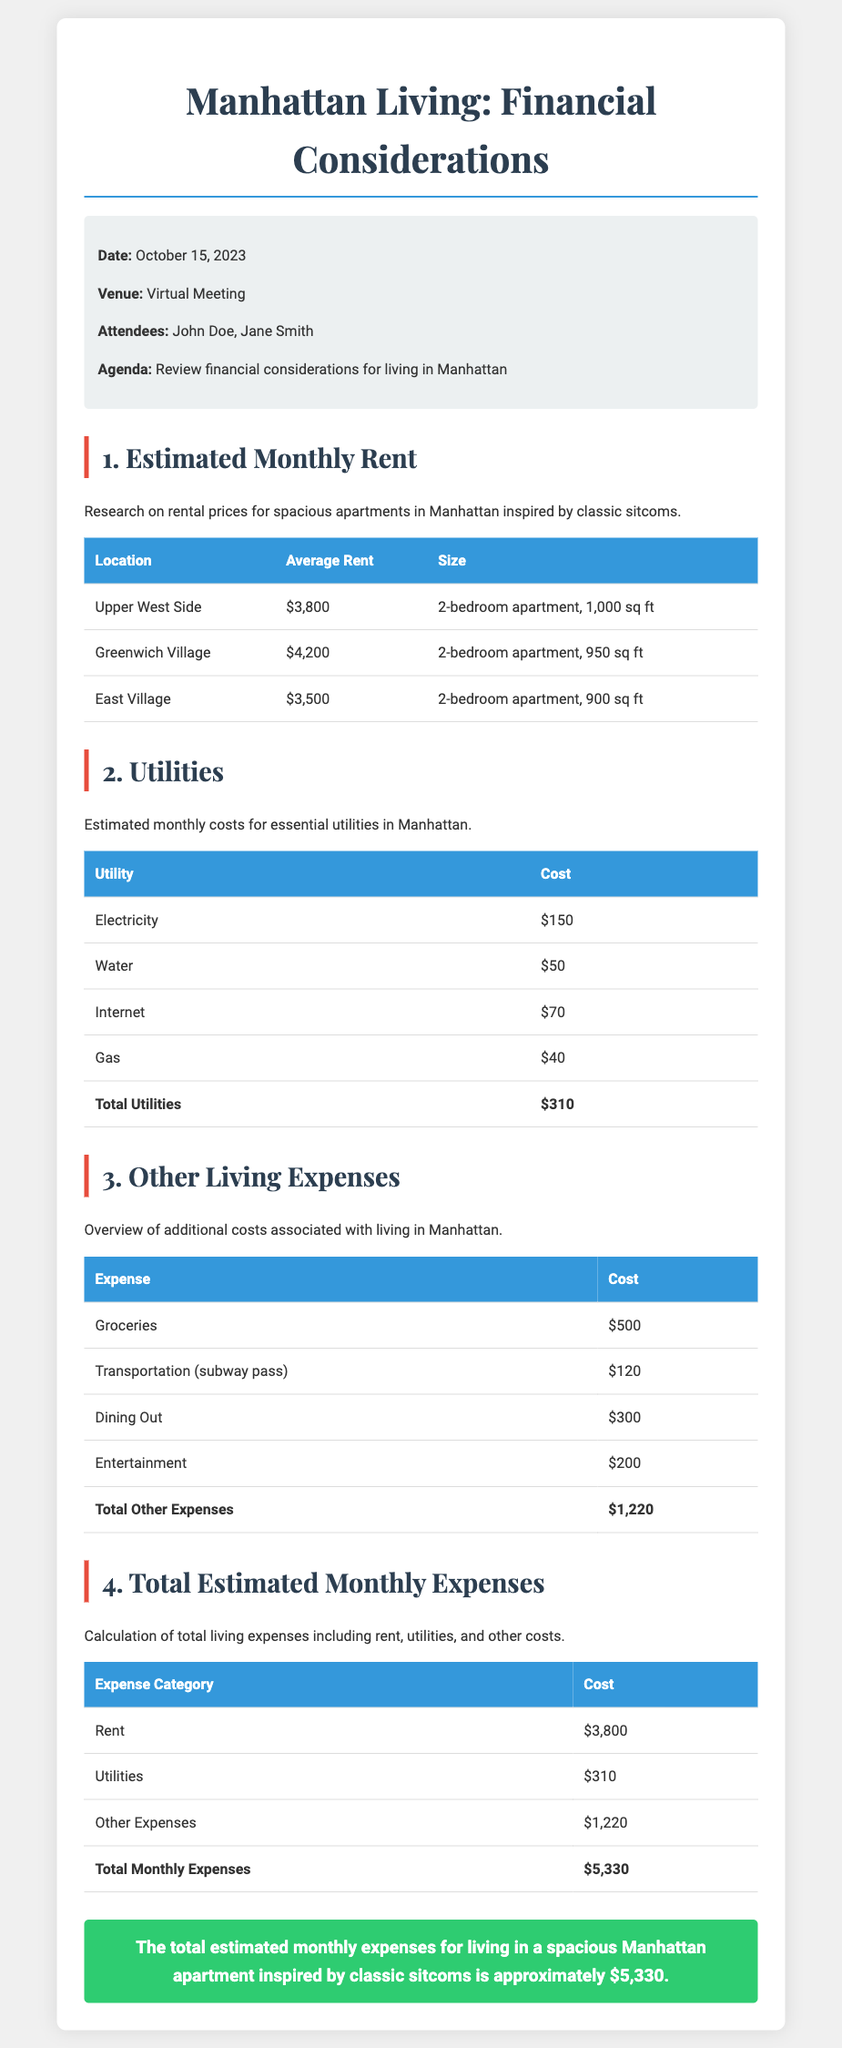what is the date of the meeting? The date of the meeting is explicitly mentioned in the info box at the top of the document, which states October 15, 2023.
Answer: October 15, 2023 how much is the average rent for a 2-bedroom apartment in Greenwich Village? The average rent for a 2-bedroom apartment in Greenwich Village is provided in the table under the "Estimated Monthly Rent" section as $4,200.
Answer: $4,200 what are the estimated monthly costs for utilities? The total estimated monthly costs for utilities is summarized in the utilities table, which indicates the total is $310.
Answer: $310 what is the total estimated monthly expense for rent, utilities, and other expenses? The total estimated monthly expenses is calculated at the bottom of the "Total Estimated Monthly Expenses" table, summing up as $5,330.
Answer: $5,330 how much do groceries cost per month? The document lists groceries as costing $500 per month in the "Other Living Expenses" section.
Answer: $500 what utility has the highest estimated cost? Among the utilities listed, electricity has the highest estimated cost, which is noted as $150 in the utilities table.
Answer: Electricity how many attendees were present at the meeting? The info box notes that there were two attendees at the meeting: John Doe and Jane Smith.
Answer: 2 what is the average rent for a 2-bedroom apartment on the Upper West Side? The average rent for a 2-bedroom apartment on the Upper West Side is specifically mentioned as $3,800 in the "Estimated Monthly Rent" section.
Answer: $3,800 what is the cost of the transportation subway pass? The transportation subway pass cost is detailed under the "Other Living Expenses" section, which specifies it as $120.
Answer: $120 